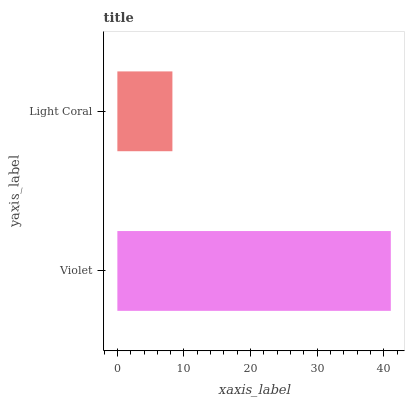Is Light Coral the minimum?
Answer yes or no. Yes. Is Violet the maximum?
Answer yes or no. Yes. Is Light Coral the maximum?
Answer yes or no. No. Is Violet greater than Light Coral?
Answer yes or no. Yes. Is Light Coral less than Violet?
Answer yes or no. Yes. Is Light Coral greater than Violet?
Answer yes or no. No. Is Violet less than Light Coral?
Answer yes or no. No. Is Violet the high median?
Answer yes or no. Yes. Is Light Coral the low median?
Answer yes or no. Yes. Is Light Coral the high median?
Answer yes or no. No. Is Violet the low median?
Answer yes or no. No. 